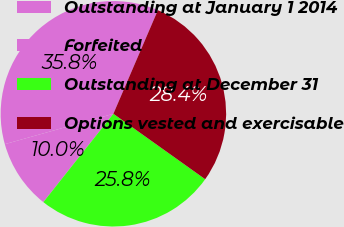Convert chart to OTSL. <chart><loc_0><loc_0><loc_500><loc_500><pie_chart><fcel>Outstanding at January 1 2014<fcel>Forfeited<fcel>Outstanding at December 31<fcel>Options vested and exercisable<nl><fcel>35.8%<fcel>9.99%<fcel>25.81%<fcel>28.4%<nl></chart> 